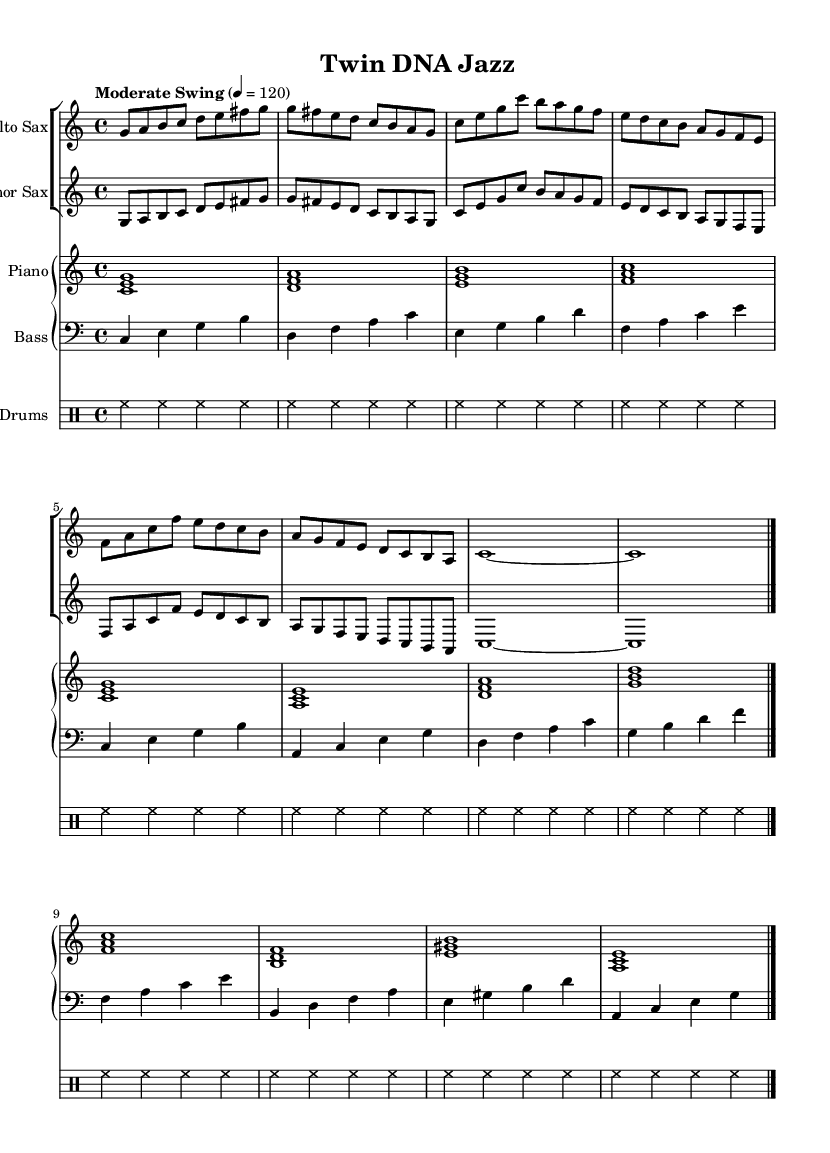What is the key signature of this music? The key signature is C major, which has no sharps or flats.
Answer: C major What is the time signature of the piece? The time signature is indicated at the beginning of the sheet music as 4/4, which means there are four beats per measure.
Answer: 4/4 What is the tempo marking for this piece? The tempo marking states "Moderate Swing," indicating a specific style and speed for performance.
Answer: Moderate Swing How many measures does the Alto Sax part contain? The Alto Sax part has a total of 8 measures, each containing either 2 or 4 beats based on the time signature of 4/4.
Answer: 8 measures Which instruments are included in this piece? The score consists of Alto Sax, Tenor Sax, Piano, Bass, and Drums, as indicated by the separate staves for each instrument in the layout.
Answer: Alto Sax, Tenor Sax, Piano, Bass, Drums What type of harmony is predominantly featured in the Piano part? The Piano part displays root position triads (chords built on the first, third, and fifth scale degrees), creating a strong harmonic foundation typical in Jazz.
Answer: Root position triads Which rhythmic pattern is most frequently used in the Drums section? The Drums section predominantly uses the hi-hat pattern, marked by repeated quarter notes, which establishes the swing feel characteristic of Jazz music.
Answer: Hi-hat pattern 